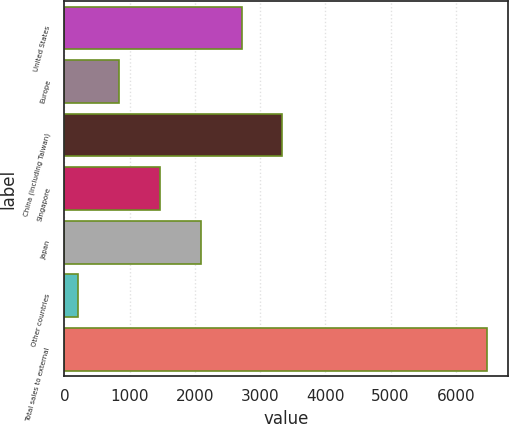<chart> <loc_0><loc_0><loc_500><loc_500><bar_chart><fcel>United States<fcel>Europe<fcel>China (including Taiwan)<fcel>Singapore<fcel>Japan<fcel>Other countries<fcel>Total sales to external<nl><fcel>2715.4<fcel>835.6<fcel>3342<fcel>1462.2<fcel>2088.8<fcel>209<fcel>6475<nl></chart> 